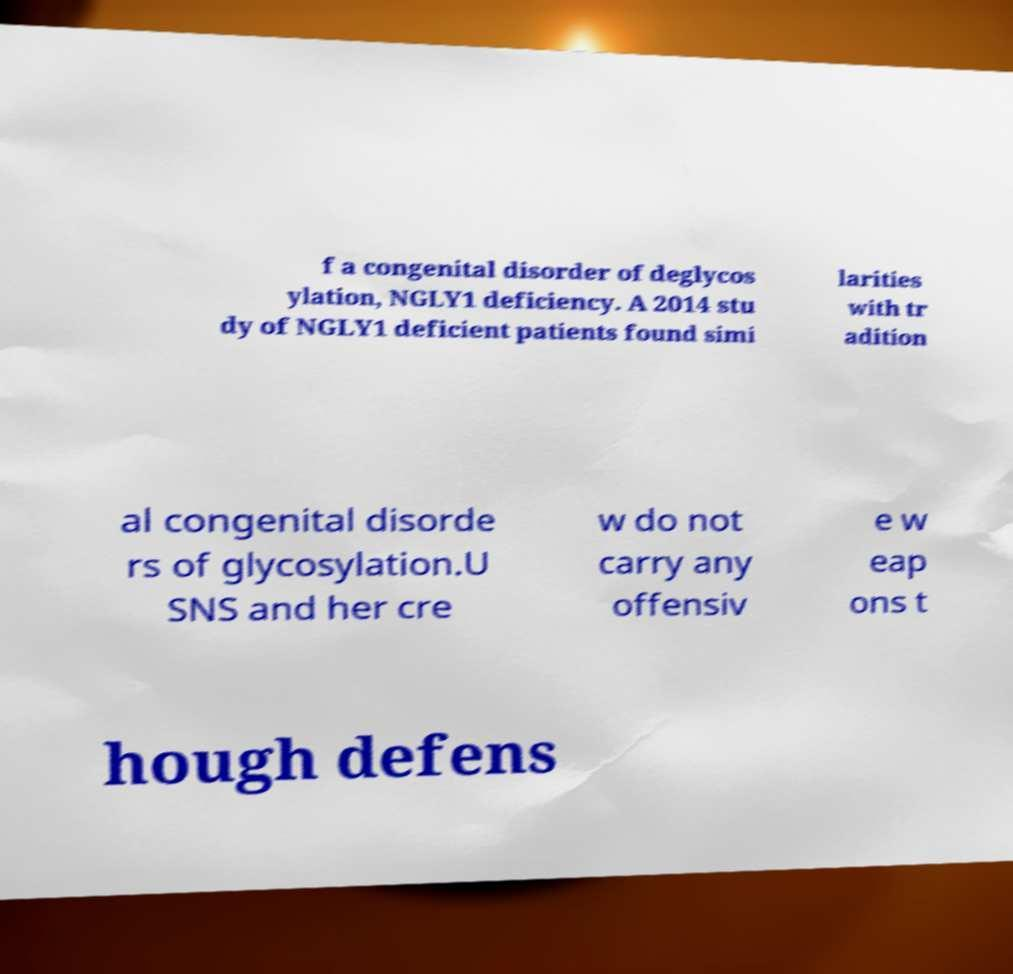Could you extract and type out the text from this image? f a congenital disorder of deglycos ylation, NGLY1 deficiency. A 2014 stu dy of NGLY1 deficient patients found simi larities with tr adition al congenital disorde rs of glycosylation.U SNS and her cre w do not carry any offensiv e w eap ons t hough defens 